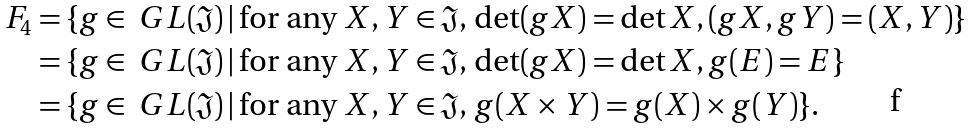Convert formula to latex. <formula><loc_0><loc_0><loc_500><loc_500>F _ { 4 } & = \{ g \in \ G L ( \mathfrak { J } ) \, | \, \text {for any $X,Y\in\mathfrak{J}$, $\det(gX)=\det X,(gX,gY)=(X,Y)$} \} \\ & = \{ g \in \ G L ( \mathfrak { J } ) \, | \, \text {for any $X,Y\in\mathfrak{J}$, $\det(gX)=\det X, g(E)=E$} \} \\ & = \{ g \in \ G L ( \mathfrak { J } ) \, | \, \text {for any $X,Y\in\mathfrak{J}$, $g(X\times Y)=g(X)\times g(Y)$} \} .</formula> 